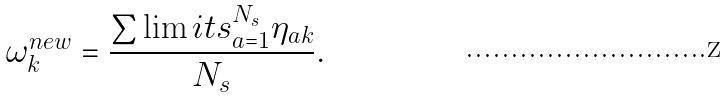Convert formula to latex. <formula><loc_0><loc_0><loc_500><loc_500>\omega _ { k } ^ { n e w } = \frac { \sum \lim i t s _ { a = 1 } ^ { N _ { s } } \eta _ { a k } } { N _ { s } } .</formula> 